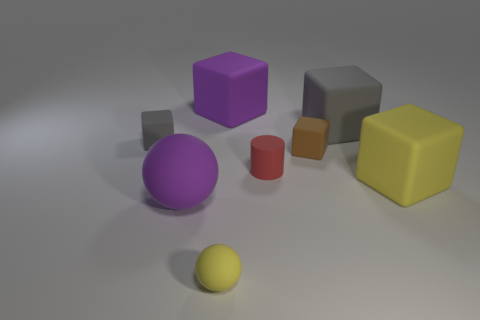What is the size of the gray matte block that is to the right of the matte cube to the left of the purple thing behind the yellow matte cube?
Your answer should be very brief. Large. What number of big yellow matte cubes are on the right side of the small cylinder?
Your answer should be compact. 1. There is a sphere that is behind the yellow rubber thing to the left of the rubber cylinder; what is its material?
Offer a terse response. Rubber. Do the purple cube and the red rubber thing have the same size?
Offer a very short reply. No. What number of things are either purple matte things that are in front of the yellow block or yellow objects that are in front of the purple sphere?
Ensure brevity in your answer.  2. Is the number of brown rubber cubes to the left of the small yellow thing greater than the number of tiny gray metal spheres?
Ensure brevity in your answer.  No. What number of other objects are there of the same shape as the tiny brown object?
Offer a very short reply. 4. What is the big block that is both right of the tiny red thing and behind the small red thing made of?
Keep it short and to the point. Rubber. What number of things are tiny rubber things or big green objects?
Offer a very short reply. 4. Are there more cubes than tiny brown rubber objects?
Ensure brevity in your answer.  Yes. 